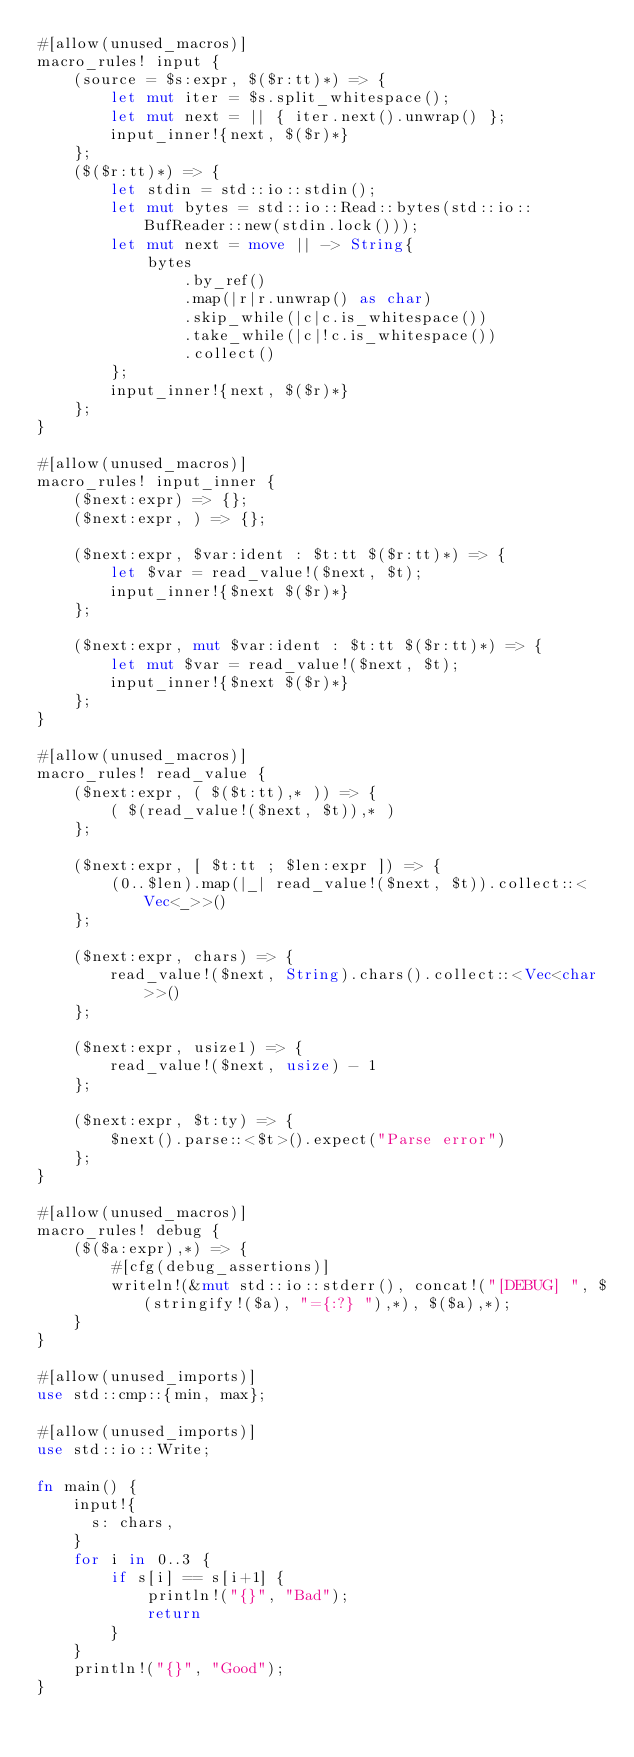Convert code to text. <code><loc_0><loc_0><loc_500><loc_500><_Rust_>#[allow(unused_macros)]
macro_rules! input {
    (source = $s:expr, $($r:tt)*) => {
        let mut iter = $s.split_whitespace();
        let mut next = || { iter.next().unwrap() };
        input_inner!{next, $($r)*}
    };
    ($($r:tt)*) => {
        let stdin = std::io::stdin();
        let mut bytes = std::io::Read::bytes(std::io::BufReader::new(stdin.lock()));
        let mut next = move || -> String{
            bytes
                .by_ref()
                .map(|r|r.unwrap() as char)
                .skip_while(|c|c.is_whitespace())
                .take_while(|c|!c.is_whitespace())
                .collect()
        };
        input_inner!{next, $($r)*}
    };
}

#[allow(unused_macros)]
macro_rules! input_inner {
    ($next:expr) => {};
    ($next:expr, ) => {};

    ($next:expr, $var:ident : $t:tt $($r:tt)*) => {
        let $var = read_value!($next, $t);
        input_inner!{$next $($r)*}
    };

    ($next:expr, mut $var:ident : $t:tt $($r:tt)*) => {
        let mut $var = read_value!($next, $t);
        input_inner!{$next $($r)*}
    };
}

#[allow(unused_macros)]
macro_rules! read_value {
    ($next:expr, ( $($t:tt),* )) => {
        ( $(read_value!($next, $t)),* )
    };

    ($next:expr, [ $t:tt ; $len:expr ]) => {
        (0..$len).map(|_| read_value!($next, $t)).collect::<Vec<_>>()
    };

    ($next:expr, chars) => {
        read_value!($next, String).chars().collect::<Vec<char>>()
    };

    ($next:expr, usize1) => {
        read_value!($next, usize) - 1
    };

    ($next:expr, $t:ty) => {
        $next().parse::<$t>().expect("Parse error")
    };
}

#[allow(unused_macros)]
macro_rules! debug {
    ($($a:expr),*) => {
        #[cfg(debug_assertions)]
        writeln!(&mut std::io::stderr(), concat!("[DEBUG] ", $(stringify!($a), "={:?} "),*), $($a),*);
    }
}

#[allow(unused_imports)]
use std::cmp::{min, max};

#[allow(unused_imports)]
use std::io::Write;

fn main() {
    input!{
      s: chars,
    }
    for i in 0..3 {
        if s[i] == s[i+1] {
            println!("{}", "Bad");
            return
        }
    }
    println!("{}", "Good");
}
</code> 